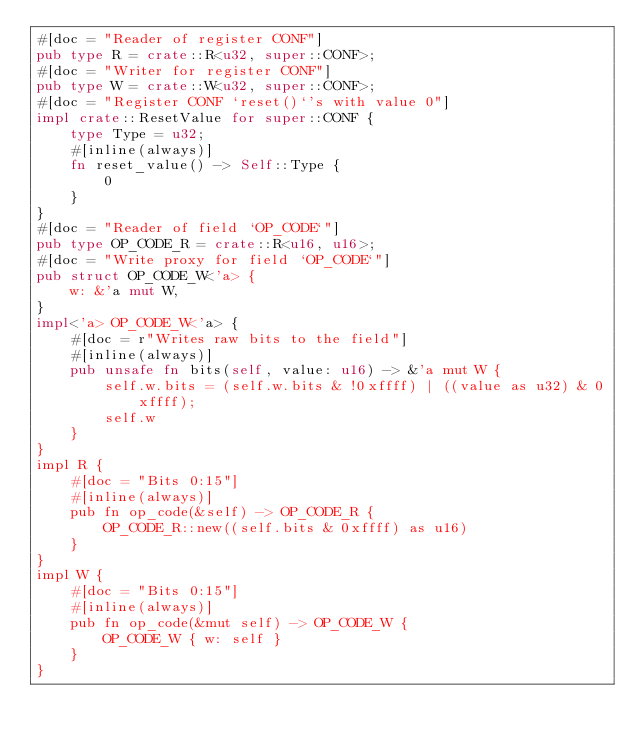<code> <loc_0><loc_0><loc_500><loc_500><_Rust_>#[doc = "Reader of register CONF"]
pub type R = crate::R<u32, super::CONF>;
#[doc = "Writer for register CONF"]
pub type W = crate::W<u32, super::CONF>;
#[doc = "Register CONF `reset()`'s with value 0"]
impl crate::ResetValue for super::CONF {
    type Type = u32;
    #[inline(always)]
    fn reset_value() -> Self::Type {
        0
    }
}
#[doc = "Reader of field `OP_CODE`"]
pub type OP_CODE_R = crate::R<u16, u16>;
#[doc = "Write proxy for field `OP_CODE`"]
pub struct OP_CODE_W<'a> {
    w: &'a mut W,
}
impl<'a> OP_CODE_W<'a> {
    #[doc = r"Writes raw bits to the field"]
    #[inline(always)]
    pub unsafe fn bits(self, value: u16) -> &'a mut W {
        self.w.bits = (self.w.bits & !0xffff) | ((value as u32) & 0xffff);
        self.w
    }
}
impl R {
    #[doc = "Bits 0:15"]
    #[inline(always)]
    pub fn op_code(&self) -> OP_CODE_R {
        OP_CODE_R::new((self.bits & 0xffff) as u16)
    }
}
impl W {
    #[doc = "Bits 0:15"]
    #[inline(always)]
    pub fn op_code(&mut self) -> OP_CODE_W {
        OP_CODE_W { w: self }
    }
}
</code> 